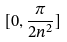<formula> <loc_0><loc_0><loc_500><loc_500>[ 0 , \frac { \pi } { 2 n ^ { 2 } } ]</formula> 